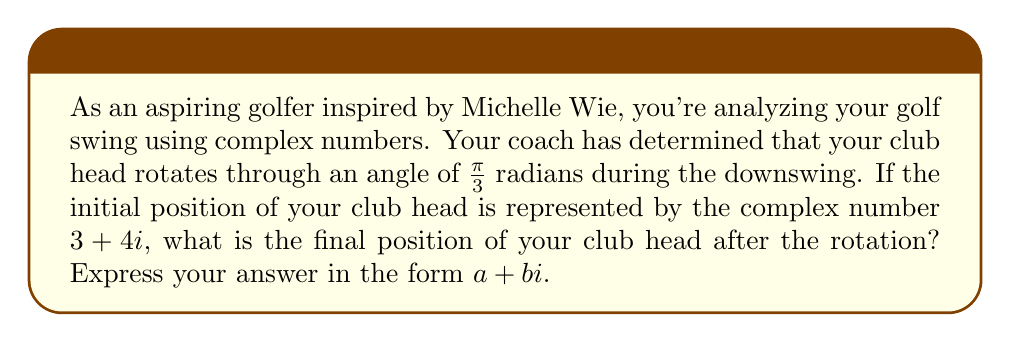Solve this math problem. To solve this problem, we'll use the concept of rotating a complex number in the complex plane. Here's a step-by-step approach:

1) The rotation of a complex number $z$ by an angle $\theta$ counterclockwise around the origin is given by the formula:

   $z' = z \cdot (\cos\theta + i\sin\theta)$

2) In this case, $z = 3 + 4i$ and $\theta = \frac{\pi}{3}$

3) We need to calculate $\cos\frac{\pi}{3}$ and $\sin\frac{\pi}{3}$:
   
   $\cos\frac{\pi}{3} = \frac{1}{2}$
   $\sin\frac{\pi}{3} = \frac{\sqrt{3}}{2}$

4) Now, let's substitute these values into our rotation formula:

   $z' = (3 + 4i) \cdot (\frac{1}{2} + i\frac{\sqrt{3}}{2})$

5) Let's multiply these complex numbers:
   
   $z' = (3 \cdot \frac{1}{2} - 4 \cdot \frac{\sqrt{3}}{2}) + (3 \cdot \frac{\sqrt{3}}{2} + 4 \cdot \frac{1}{2})i$

6) Simplify:
   
   $z' = (\frac{3}{2} - 2\sqrt{3}) + (\frac{3\sqrt{3}}{2} + 2)i$

7) This is our final answer in the form $a + bi$.
Answer: $(\frac{3}{2} - 2\sqrt{3}) + (\frac{3\sqrt{3}}{2} + 2)i$ 